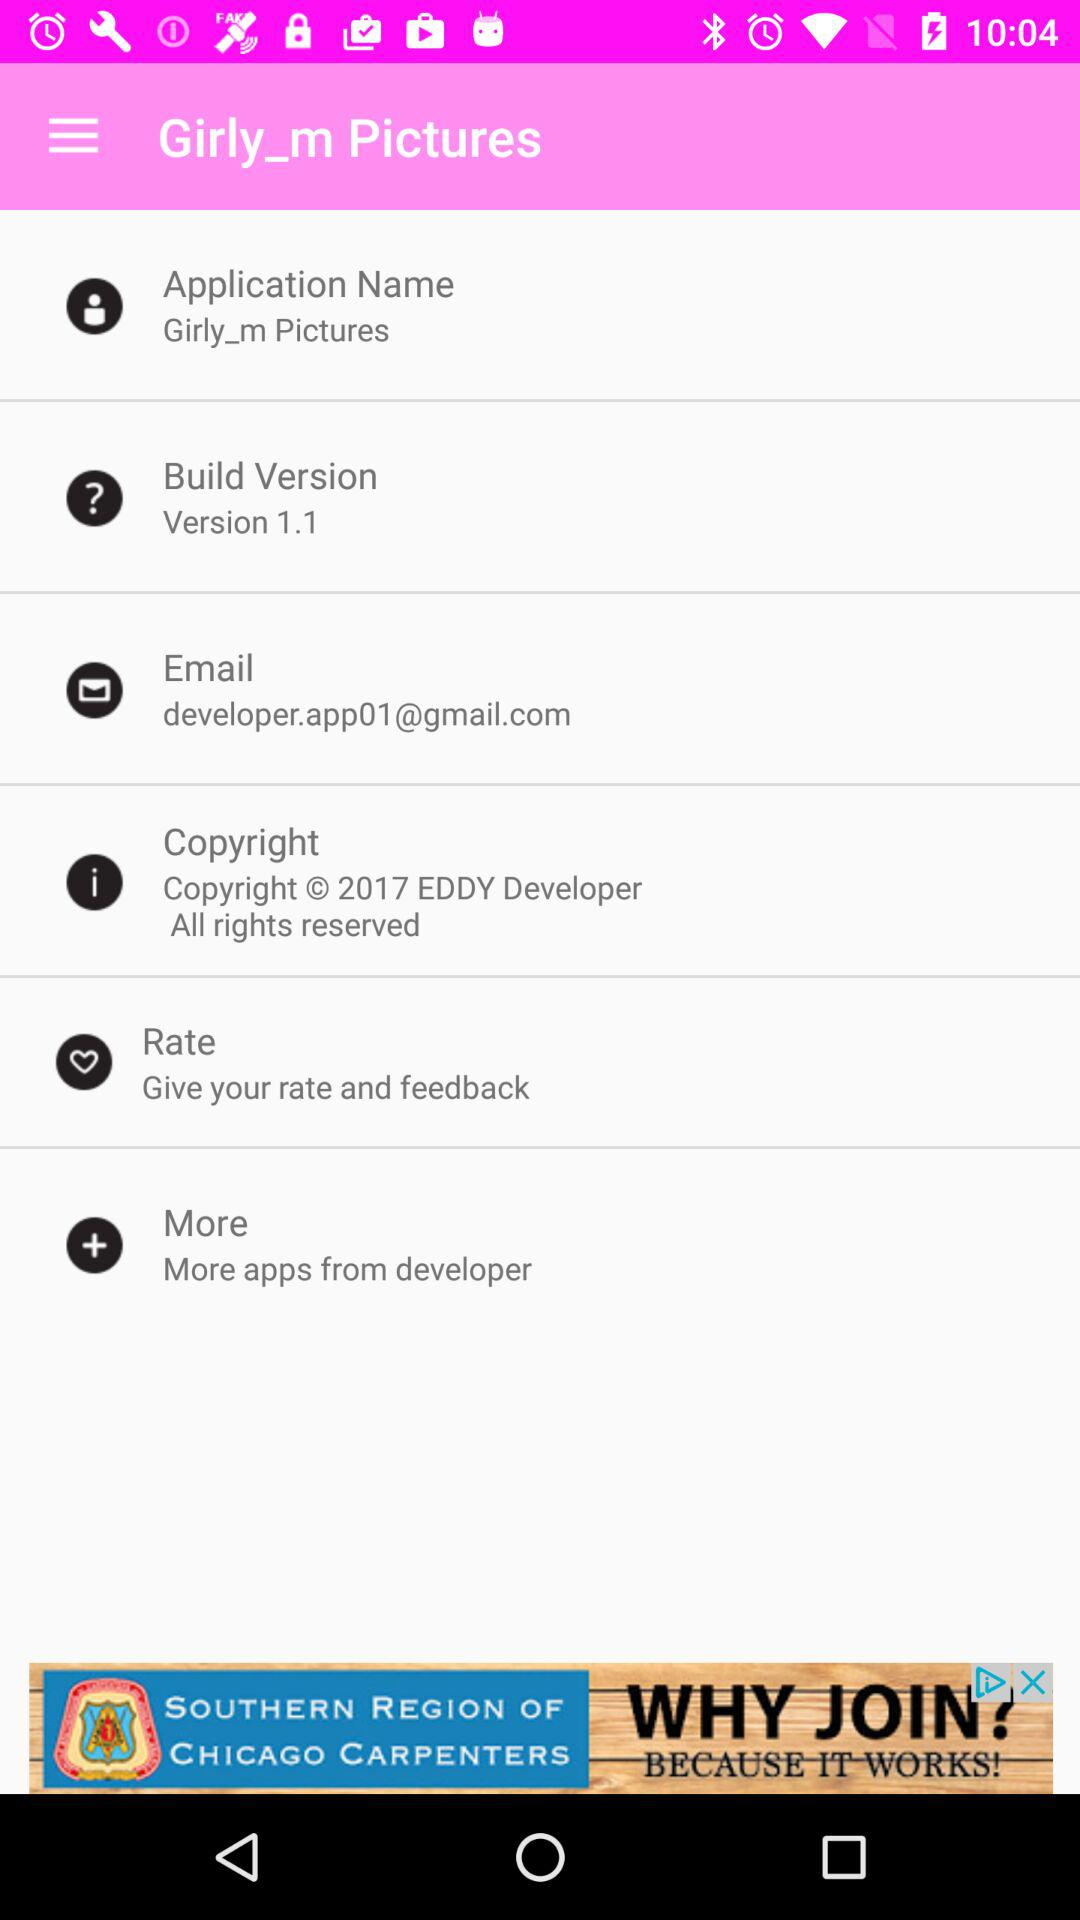What is the given email address? The given email address is developer.app01@gmail.com. 